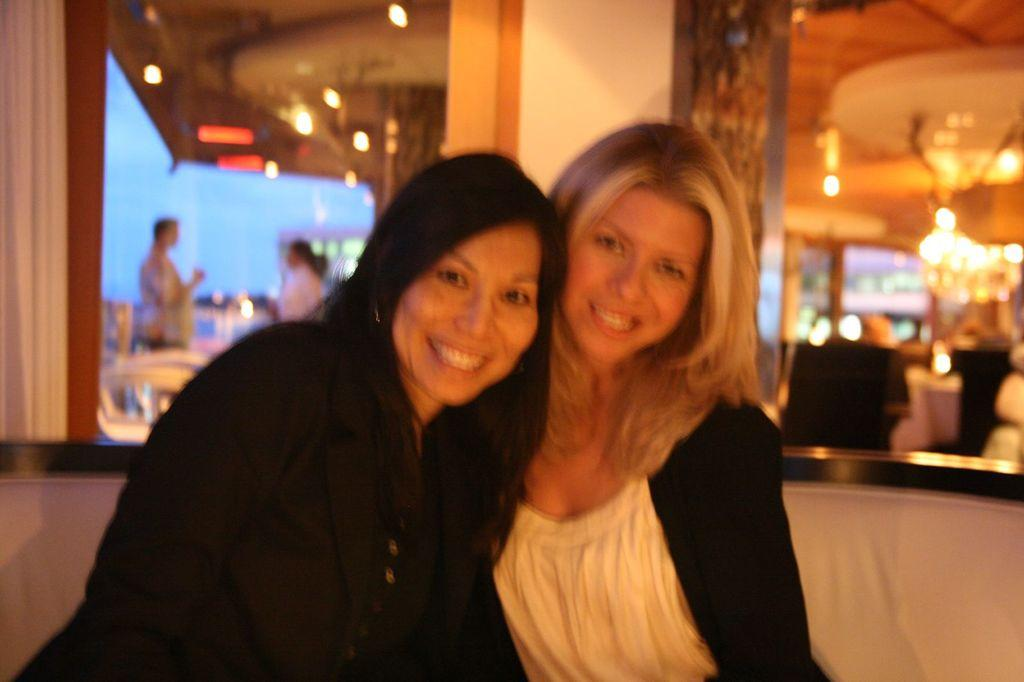How many women are sitting in the foreground of the image? There are two women sitting on a chair in the foreground of the image. What is happening in the background of the image? A: There are two persons standing in the background of the image, and there is a group of chairs and lights visible. What can be seen in the sky in the background of the image? The sky is visible in the background of the image. What type of fruit is being used as a cushion for the elbow of one of the women in the image? There is no fruit present in the image, and no one is using their elbow as a cushion. 